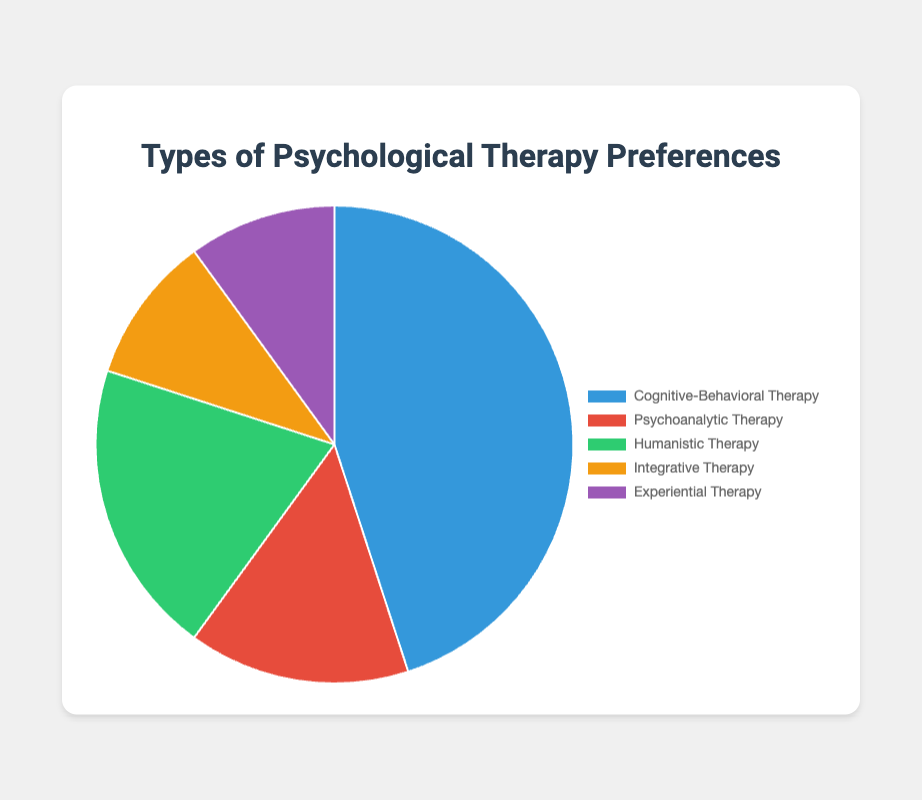What is the most preferred type of psychological therapy among patients? To determine the most preferred type, look at the segment with the highest percentage. Cognitive-Behavioral Therapy has the largest portion at 45%.
Answer: Cognitive-Behavioral Therapy What percentage of patients prefer Humanistic Therapy and Integrative Therapy combined? Add the percentages of Humanistic Therapy (20%) and Integrative Therapy (10%). 20% + 10% = 30%.
Answer: 30% Which therapy type is least preferred by patients? Identify the segment with the smallest percentage. Both Integrative Therapy and Experiential Therapy have the smallest portion at 10% each.
Answer: Integrative Therapy and Experiential Therapy How much more popular is Cognitive-Behavioral Therapy compared to Psychoanalytic Therapy? Subtract the percentage of Psychoanalytic Therapy (15%) from Cognitive-Behavioral Therapy (45%). 45% - 15% = 30%.
Answer: 30% What therapy type has double the preference of Integrative Therapy? Double the percentage of Integrative Therapy (10%) is 20%, which matches Humanistic Therapy's percentage.
Answer: Humanistic Therapy If Experiential Therapy's preference increased by 5%, what would the new percentage be? Add 5% to the current percentage of Experiential Therapy (10%). 10% + 5% = 15%.
Answer: 15% Which color represents the segment for Psychoanalytic Therapy in the chart? Look at the segment labeled Psychoanalytic Therapy and identify its color. The second segment in red represents Psychoanalytic Therapy.
Answer: Red By what percentage do Humanistic Therapy preferences exceed Psychoanalytic Therapy preferences? Subtract the percentage of Psychoanalytic Therapy (15%) from Humanistic Therapy (20%). 20% - 15% = 5%.
Answer: 5% If 200 patients were surveyed, how many preferred Cognitive-Behavioral Therapy? Calculate 45% of 200 by multiplying 200 by 0.45. 200 * 0.45 = 90.
Answer: 90 What fraction of the total preferences does Integrative Therapy occupy? Convert the percentage to a fraction by dividing by 100. Integrative Therapy occupies 10%, so 10/100 simplifies to 1/10.
Answer: 1/10 